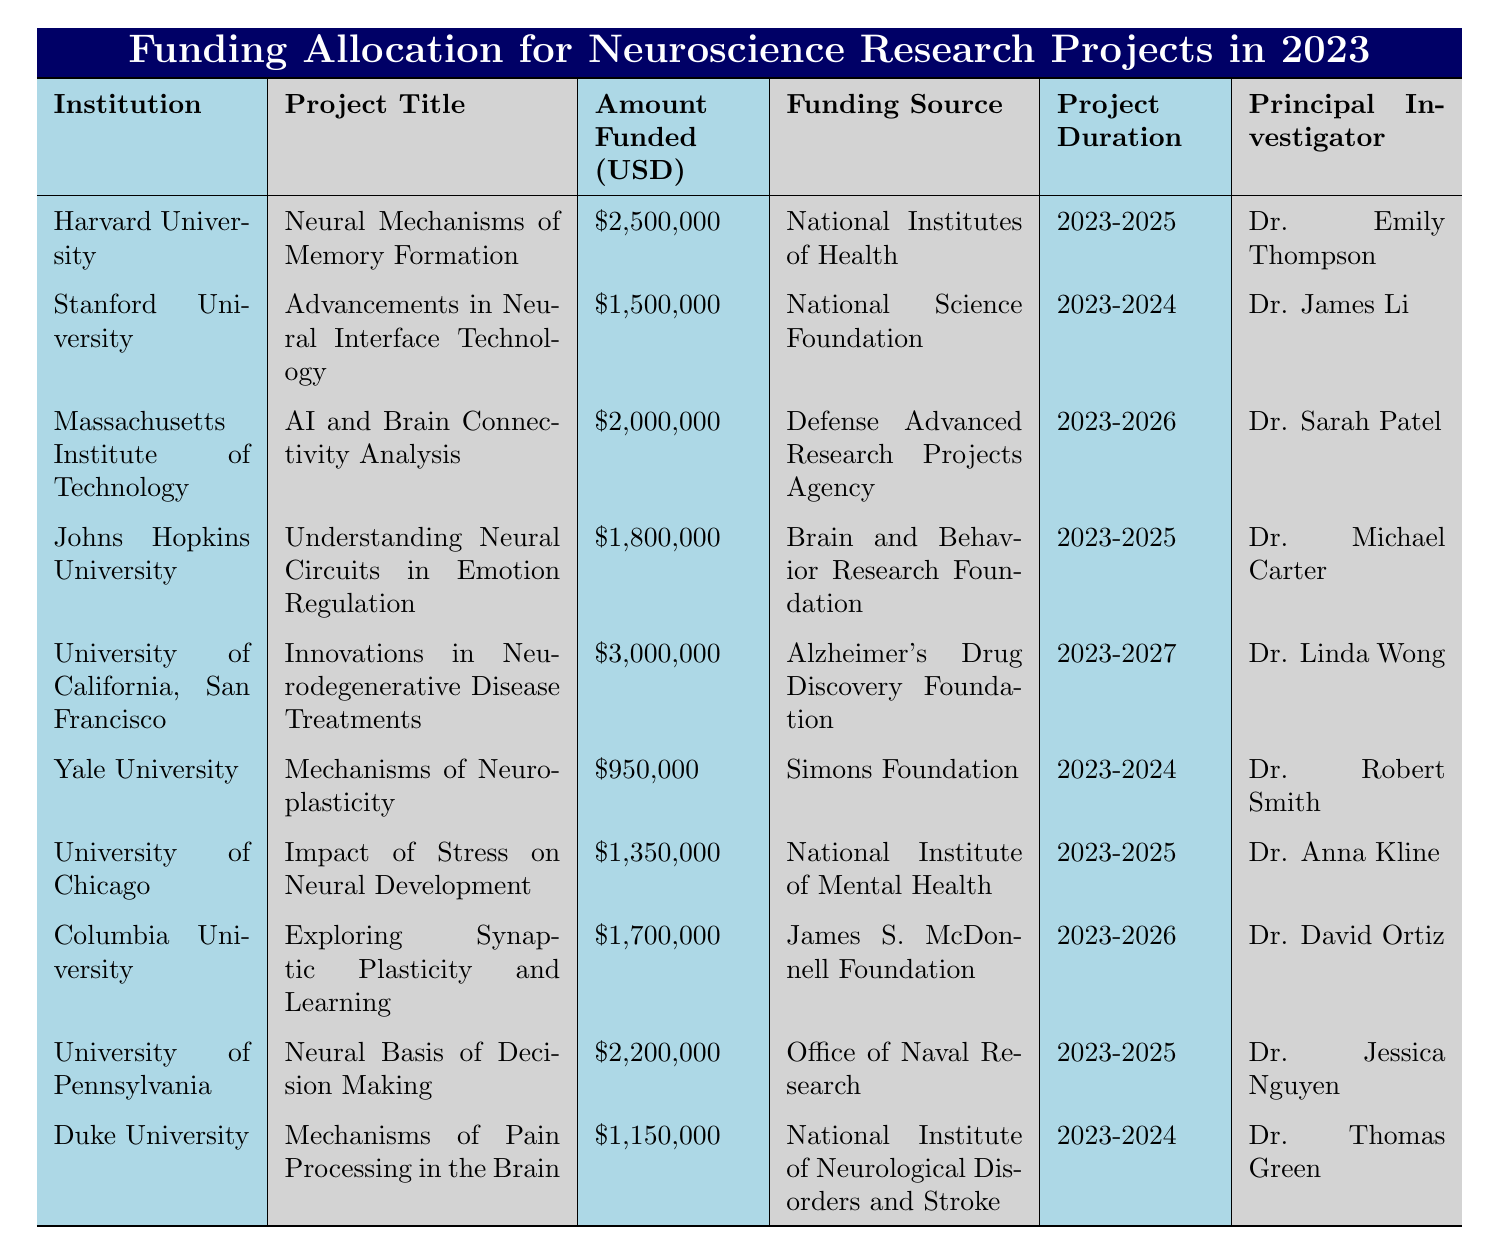What is the total amount funded for neuroscience research projects in 2023? To find the total funding, sum the amounts funded for all projects listed in the table: \$2,500,000 + \$1,500,000 + \$2,000,000 + \$1,800,000 + \$3,000,000 + \$950,000 + \$1,350,000 + \$1,700,000 + \$2,200,000 + \$1,150,000 = \$17,150,000.
Answer: \$17,150,000 Which institution has the highest funding allocation for a project in 2023? By comparing the amounts funded for each project, the maximum is \$3,000,000 provided to the University of California, San Francisco for the project "Innovations in Neurodegenerative Disease Treatments."
Answer: University of California, San Francisco How many projects are funded for a duration of 2023-2025? By counting the projects in the table that have a duration listed as 2023-2025, we find there are 5 projects: Harvard University, Johns Hopkins University, University of Chicago, University of Pennsylvania, and Massachusetts Institute of Technology.
Answer: 5 Is there a project funded by the National Science Foundation? The table shows that Stanford University received funding from the National Science Foundation for the project "Advancements in Neural Interface Technology."
Answer: Yes What is the average amount funded for projects that are completed by 2024? Identify the projects that end in 2024: Stanford University ($1,500,000), Yale University ($950,000), and Duke University ($1,150,000). Sum these amounts: \$1,500,000 + \$950,000 + \$1,150,000 = \$3,600,000. The average is \$3,600,000 divided by 3 (the number of projects) = \$1,200,000.
Answer: \$1,200,000 Which principal investigator is associated with the project that received the least funding? The project with the least funding is "Mechanisms of Neuroplasticity" from Yale University, which is led by Dr. Robert Smith.
Answer: Dr. Robert Smith How many projects have a funding amount greater than \$2,000,000? Looking through the amounts funded, the projects that exceed \$2,000,000 are: University of California, San Francisco (\$3,000,000), Harvard University (\$2,500,000), and University of Pennsylvania (\$2,200,000). This counts to 3 projects.
Answer: 3 Which funding source supported the "AI and Brain Connectivity Analysis" project? The table specifies that the funding source for the "AI and Brain Connectivity Analysis" project at the Massachusetts Institute of Technology is the Defense Advanced Research Projects Agency.
Answer: Defense Advanced Research Projects Agency How many projects are funded by the Brain and Behavior Research Foundation? By checking the table, there is only 1 project funded by the Brain and Behavior Research Foundation, which is at Johns Hopkins University.
Answer: 1 What is the difference in funding between the highest funded project and the lowest funded project? The highest funded project is at the University of California, San Francisco with \$3,000,000, and the lowest is at Yale University with \$950,000. The difference is \$3,000,000 - \$950,000 = \$2,050,000.
Answer: \$2,050,000 